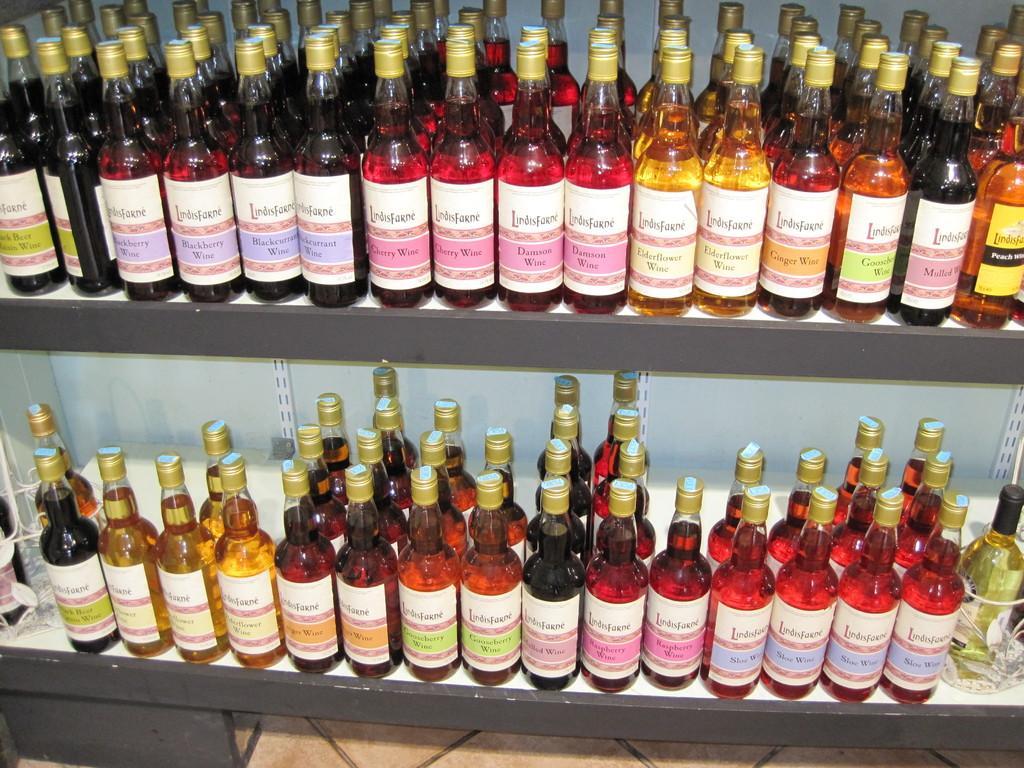How would you summarize this image in a sentence or two? In this image there are two shelves on which there are so many wine bottles kept on it. 